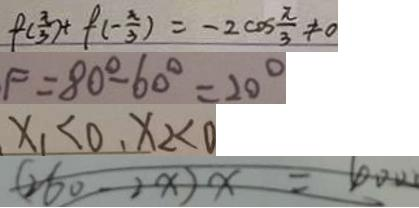<formula> <loc_0><loc_0><loc_500><loc_500>f ( \frac { \pi } { 3 } ) + f ( - \frac { \pi } { 3 } ) = - 2 \cos \frac { \pi } { 3 } \neq 0 
 F = 8 0 ^ { \circ } - 6 0 ^ { \circ } = 2 0 ^ { \circ } 
 x _ { 1 } < 0 , x _ { 2 } < 0 
 ( 2 6 0 - 2 x ) x = 1 0 0 0</formula> 